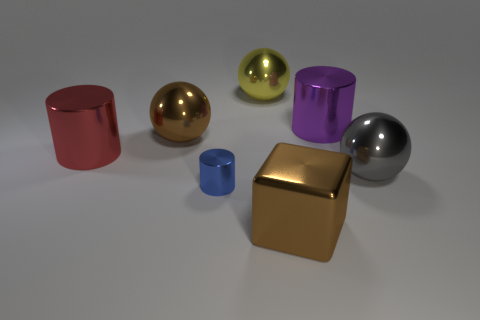Is there any other thing of the same color as the small cylinder?
Ensure brevity in your answer.  No. Is the shape of the big gray metal thing the same as the large yellow object?
Your response must be concise. Yes. There is a shiny thing that is on the right side of the purple metal cylinder; is its size the same as the metal cylinder that is in front of the large gray metal thing?
Provide a short and direct response. No. What number of objects are tiny cyan metal things or shiny cylinders that are on the left side of the small object?
Your answer should be compact. 1. The cube is what color?
Keep it short and to the point. Brown. What is the size of the brown cube that is made of the same material as the gray sphere?
Your answer should be compact. Large. Is there a sphere that has the same color as the block?
Ensure brevity in your answer.  Yes. There is a yellow thing; does it have the same size as the metal cylinder that is in front of the red thing?
Offer a very short reply. No. There is a brown object on the right side of the brown metal thing left of the small blue metal object; what number of metallic cylinders are in front of it?
Your answer should be very brief. 0. What is the size of the metallic object that is the same color as the cube?
Give a very brief answer. Large. 